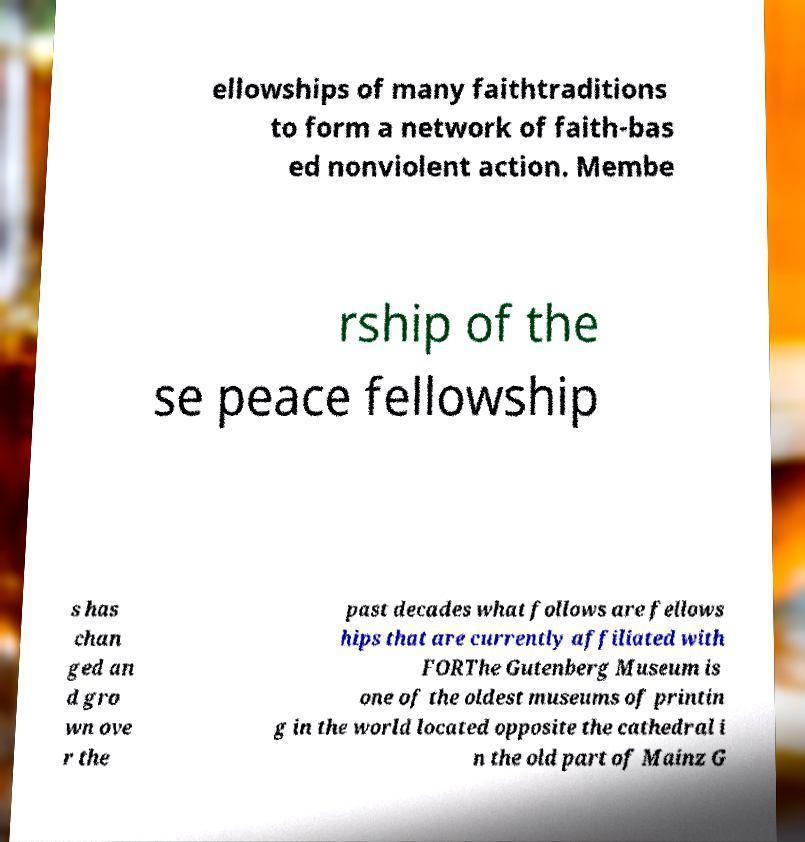Please identify and transcribe the text found in this image. ellowships of many faithtraditions to form a network of faith-bas ed nonviolent action. Membe rship of the se peace fellowship s has chan ged an d gro wn ove r the past decades what follows are fellows hips that are currently affiliated with FORThe Gutenberg Museum is one of the oldest museums of printin g in the world located opposite the cathedral i n the old part of Mainz G 